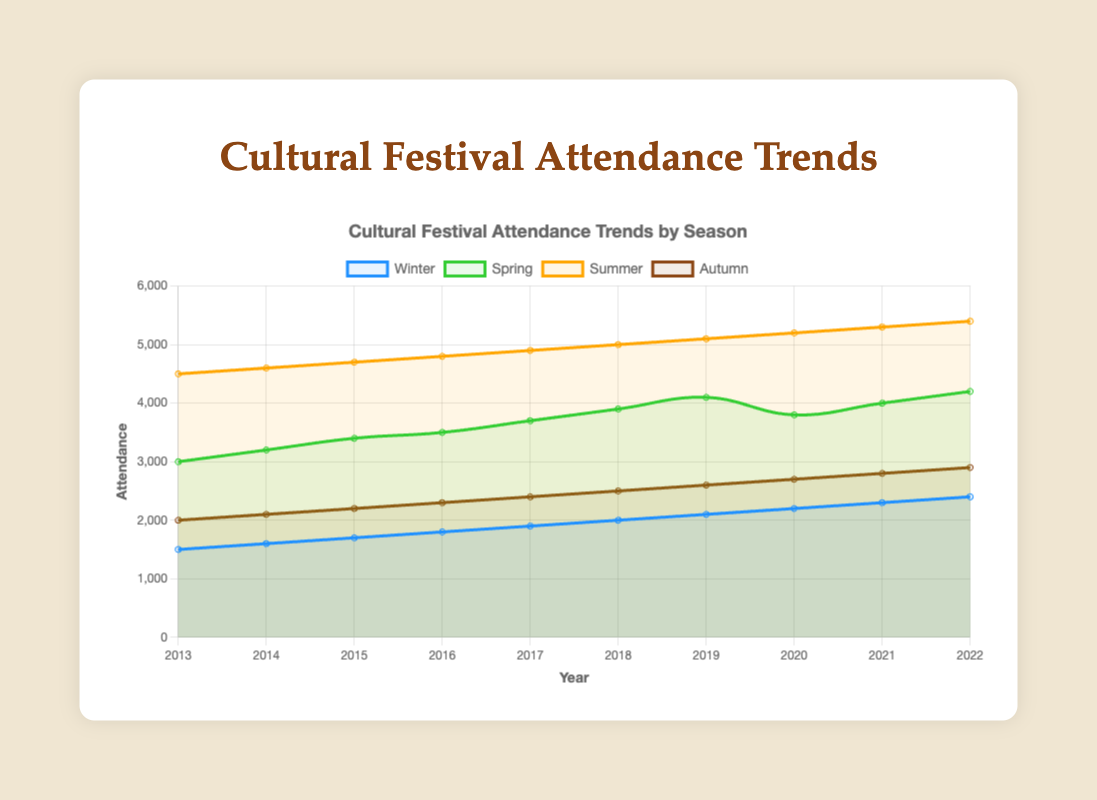Which season showed the highest attendance increase between 2013 and 2022? To find this, calculate the attendance difference for each season between 2013 and 2022: Winter (2400-1500=900), Spring (4200-3000=1200), Summer (5400-4500=900), and Autumn (2900-2000=900). The highest increase is in Spring with a growth of 1200 attendees.
Answer: Spring What was the overall trend in winter festival attendance from 2013 to 2022? Observe the line for Winter in the chart; it shows a consistent increase in attendance every year from 1500 in 2013 to 2400 in 2022.
Answer: Consistent increase Which season had the lowest attendance in 2022, and what was the value? Compare the attendance values for 2022: Winter (2400), Spring (4200), Summer (5400), and Autumn (2900). The lowest is in Winter with 2400 attendees.
Answer: Winter, 2400 In which year did spring festival attendance decrease compared to the previous year, and by how much? Look at the Spring line: Spring festival attendance decreased from 4100 in 2019 to 3800 in 2020. The decrease is 4100 - 3800 = 300.
Answer: 2020, 300 What is the average attendance for the Autumn festivals over the decade? Sum the Autumn attendance values from 2013 to 2022: (2000+2100+2200+2300+2400+2500+2600+2700+2800+2900 = 24500). Then divide by the number of years (10): 24500 / 10 = 2450.
Answer: 2450 How does the trend in Summer festival attendance from 2013 to 2022 compare to the trend in Autumn festival attendance? Compare the lines for Summer and Autumn: Both show a consistent increase each year. However, Summer has higher attendance values overall.
Answer: Both increased, but Summer had higher values What is the total attendance across all seasons in 2017? Sum the attendance for all seasons in 2017: Winter (1900) + Spring (3700) + Summer (4900) + Autumn (2400) = 12900.
Answer: 12900 Which season had the most consistent rate of increase in attendance over the decade, and how can you tell? Look at the slopes of the lines: The Winter and Summer lines both show very uniform linear increases, indicating a consistent rate of increase each year. We can verify by checking the yearly increments, which remain consistent.
Answer: Winter and Summer What was the average annual increase in Winter festival attendance over the decade? Calculate the difference between 2022 and 2013 for Winter: 2400 - 1500 = 900. Divide by the number of years (9): 900 / 9 = 100.
Answer: 100 